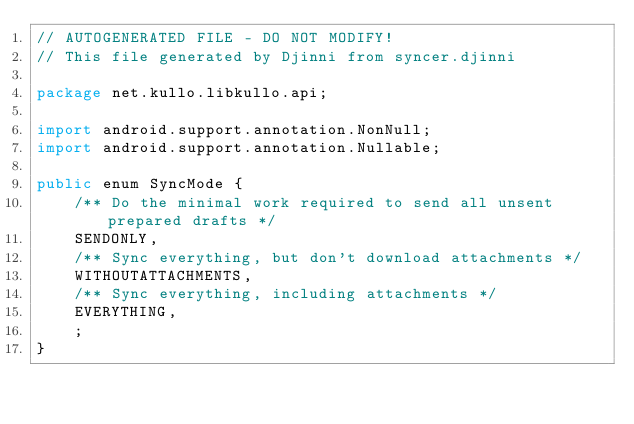Convert code to text. <code><loc_0><loc_0><loc_500><loc_500><_Java_>// AUTOGENERATED FILE - DO NOT MODIFY!
// This file generated by Djinni from syncer.djinni

package net.kullo.libkullo.api;

import android.support.annotation.NonNull;
import android.support.annotation.Nullable;

public enum SyncMode {
    /** Do the minimal work required to send all unsent prepared drafts */
    SENDONLY,
    /** Sync everything, but don't download attachments */
    WITHOUTATTACHMENTS,
    /** Sync everything, including attachments */
    EVERYTHING,
    ;
}
</code> 